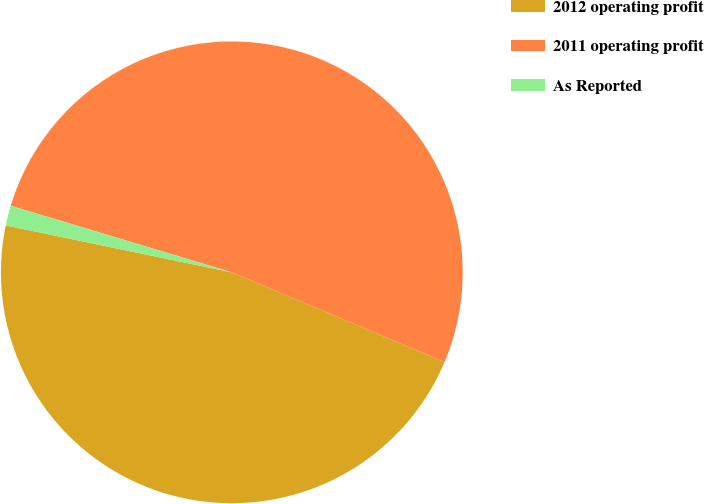<chart> <loc_0><loc_0><loc_500><loc_500><pie_chart><fcel>2012 operating profit<fcel>2011 operating profit<fcel>As Reported<nl><fcel>46.9%<fcel>51.7%<fcel>1.4%<nl></chart> 